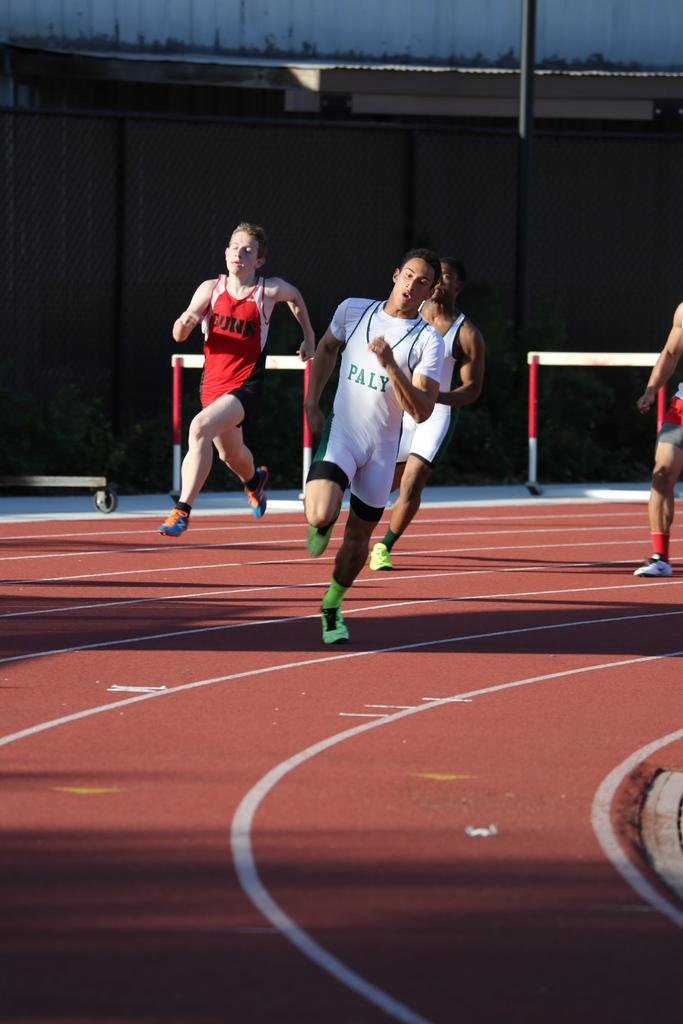How many people are in the image? There are four men in the image. What are the men doing in the image? The men are running on a running track. What color is the running track? The running track is maroon in color. What can be seen in the background of the image? There is a black color wall and a pole in the background of the image. What type of oatmeal is being served in the image? There is no oatmeal present in the image; it features four men running on a maroon-colored running track with a black wall and a pole in the background. Can you tell me how the engine is functioning in the image? There is no engine present in the image. 